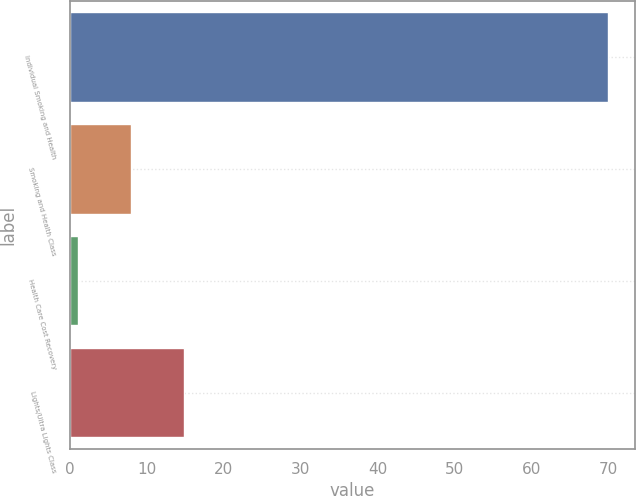Convert chart. <chart><loc_0><loc_0><loc_500><loc_500><bar_chart><fcel>Individual Smoking and Health<fcel>Smoking and Health Class<fcel>Health Care Cost Recovery<fcel>Lights/Ultra Lights Class<nl><fcel>70<fcel>7.9<fcel>1<fcel>14.8<nl></chart> 